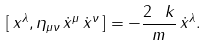<formula> <loc_0><loc_0><loc_500><loc_500>[ \, x ^ { \lambda } , \eta _ { \mu \nu } \, \dot { x } ^ { \mu } \, \dot { x } ^ { \nu } \, ] = - \frac { 2 \, \ k } { m } \, \dot { x } ^ { \lambda } .</formula> 